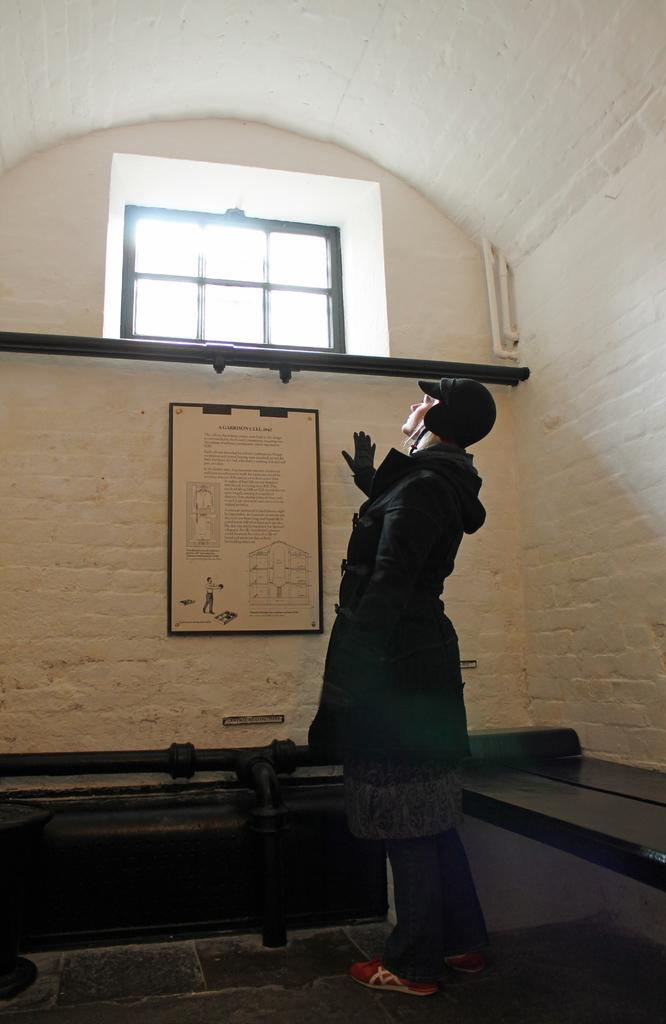What is the main subject of the image? There is a woman standing in the center of the image. What is the woman standing on? The woman is standing on the floor. What can be seen in the background of the image? There is a poster, a wall, ventilation, pipes, and a bench in the background of the image. What type of patch is being sewn onto the woman's clothing in the image? There is no patch or sewing activity visible in the image. How much profit is the woman making from the waste in the image? There is no waste or profit mentioned in the image; it simply features a woman standing in the center with various background elements. 